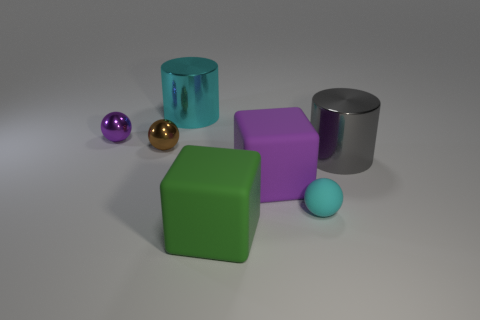Are there any tiny purple objects of the same shape as the tiny cyan rubber thing?
Ensure brevity in your answer.  Yes. There is a metallic cylinder that is in front of the big cyan metal object; are there any cylinders behind it?
Give a very brief answer. Yes. How many big cyan spheres have the same material as the tiny purple ball?
Keep it short and to the point. 0. Are any small red cubes visible?
Offer a very short reply. No. How many large things have the same color as the rubber sphere?
Give a very brief answer. 1. Does the large gray cylinder have the same material as the sphere that is right of the purple matte block?
Keep it short and to the point. No. Are there more metallic cylinders that are behind the big gray object than gray metallic blocks?
Make the answer very short. Yes. There is a small rubber ball; is its color the same as the cylinder left of the big purple rubber block?
Keep it short and to the point. Yes. Are there the same number of small matte things that are behind the small cyan sphere and large objects that are behind the purple rubber block?
Offer a terse response. No. There is a cyan object that is in front of the large purple rubber thing; what is it made of?
Ensure brevity in your answer.  Rubber. 